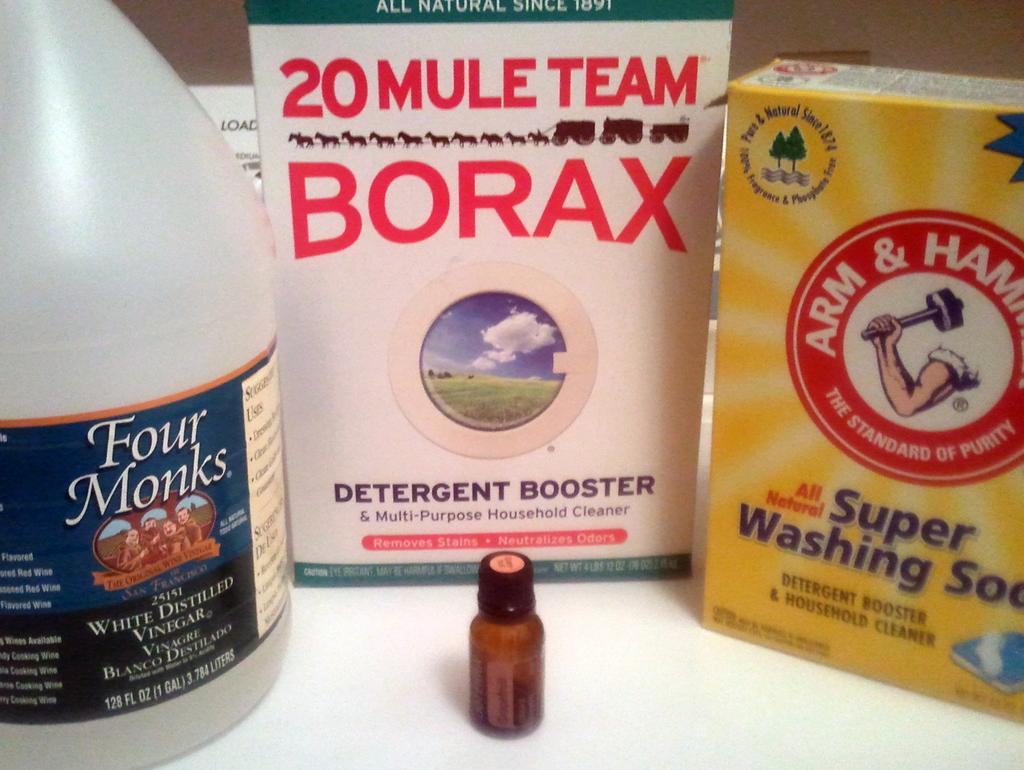What brand is on the box in the center of the image?
Make the answer very short. Borax. 